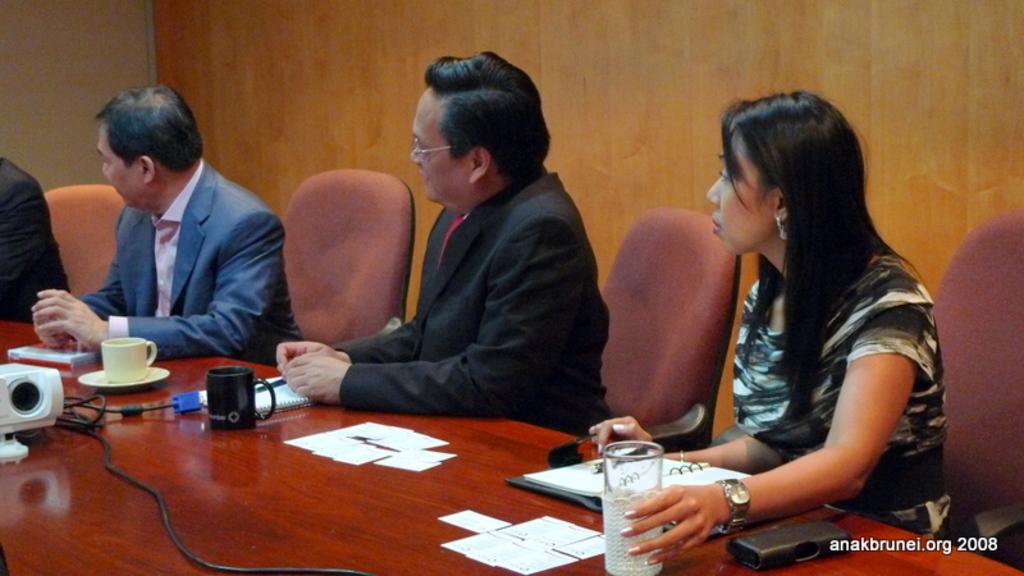Describe this image in one or two sentences. In this image I can see a person wearing black blazer and red tie is sitting on a chair, a woman wearing black and white dress is sitting on a chair and a person wearing pink shirt and blue blazer is sitting on a chair in front of a table which is brown in color and on the table I can see a projector, few cups, few wires, few papers, a file and few other objects. In the background I can see a person and the brown colored surface. 